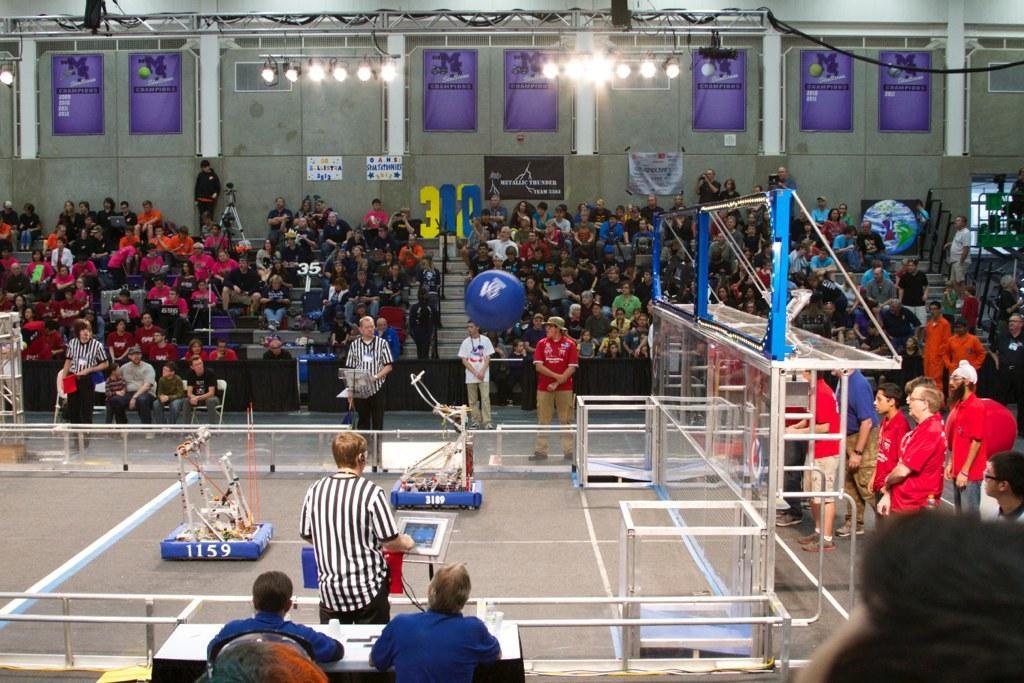In one or two sentences, can you explain what this image depicts? It is a stadium and in between the stadium the players are playing a game and around the stadium,the crowd is sitting and watching the game. 